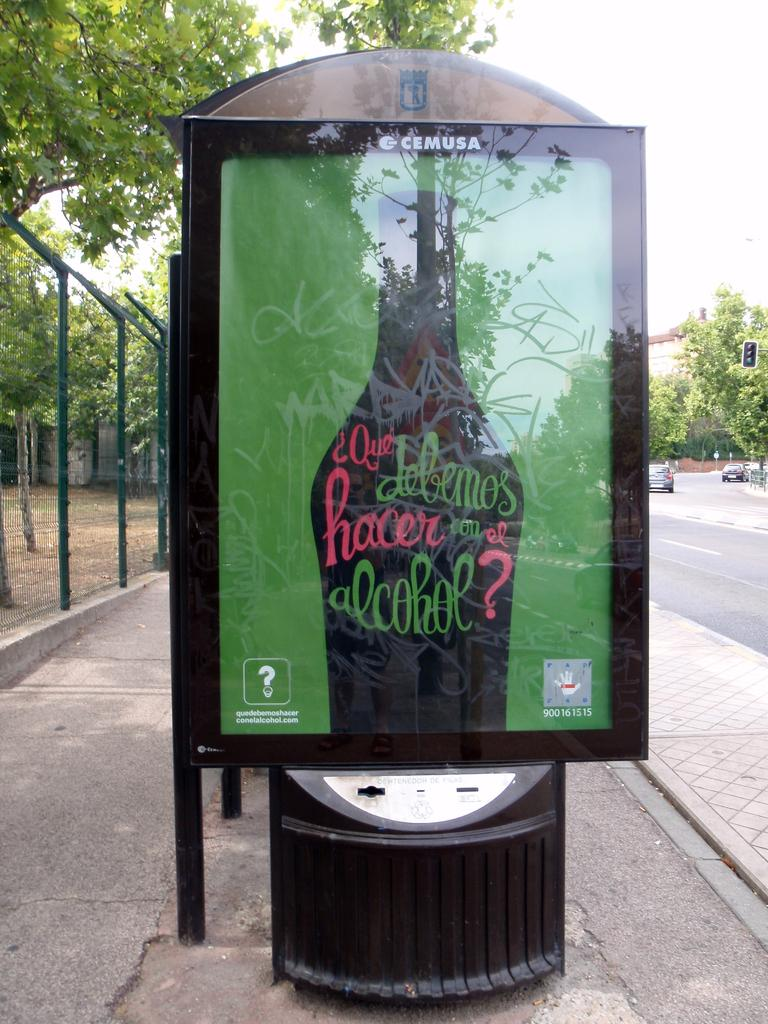Provide a one-sentence caption for the provided image. The advertisement has CEMUSA written across the top of it. 